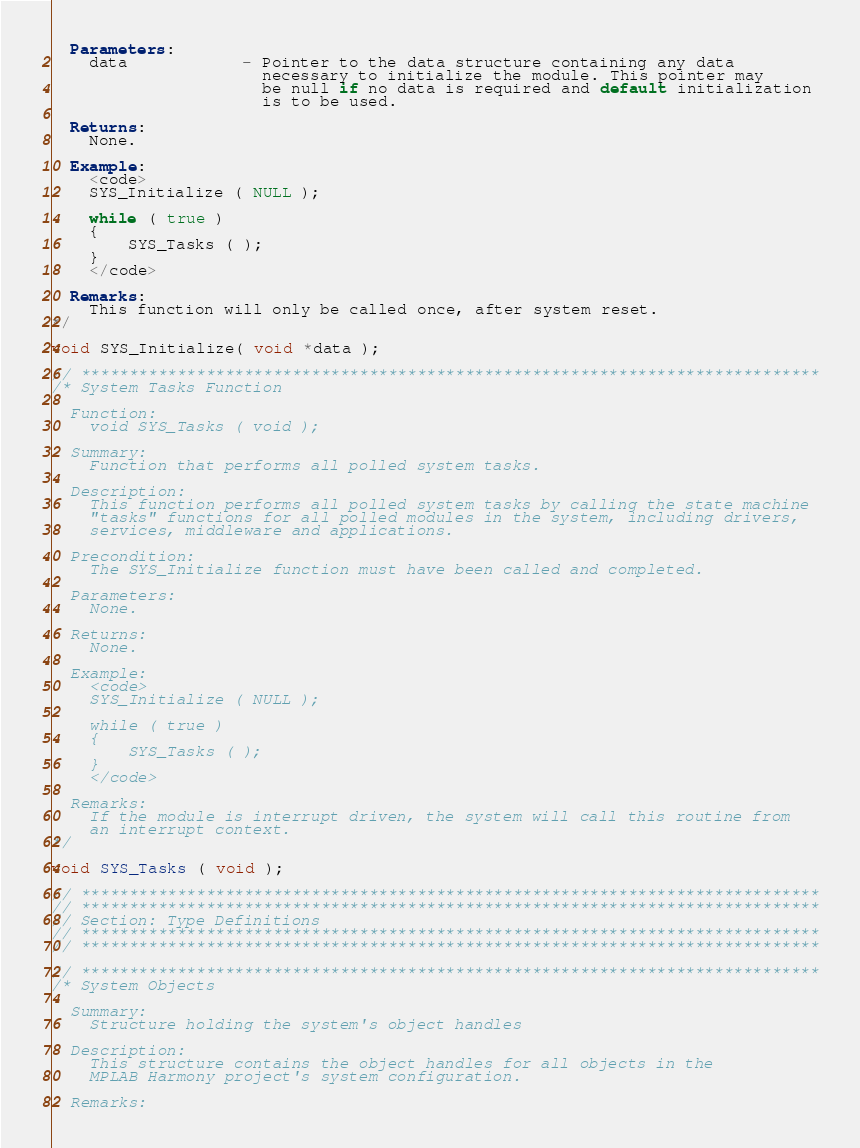<code> <loc_0><loc_0><loc_500><loc_500><_C_>  Parameters:
    data            - Pointer to the data structure containing any data
                      necessary to initialize the module. This pointer may
                      be null if no data is required and default initialization
                      is to be used.

  Returns:
    None.

  Example:
    <code>
    SYS_Initialize ( NULL );

    while ( true )
    {
        SYS_Tasks ( );
    }
    </code>

  Remarks:
    This function will only be called once, after system reset.
*/

void SYS_Initialize( void *data );

// *****************************************************************************
/* System Tasks Function

  Function:
    void SYS_Tasks ( void );

  Summary:
    Function that performs all polled system tasks.

  Description:
    This function performs all polled system tasks by calling the state machine
    "tasks" functions for all polled modules in the system, including drivers,
    services, middleware and applications.

  Precondition:
    The SYS_Initialize function must have been called and completed.

  Parameters:
    None.

  Returns:
    None.

  Example:
    <code>
    SYS_Initialize ( NULL );

    while ( true )
    {
        SYS_Tasks ( );
    }
    </code>

  Remarks:
    If the module is interrupt driven, the system will call this routine from
    an interrupt context.
*/

void SYS_Tasks ( void );

// *****************************************************************************
// *****************************************************************************
// Section: Type Definitions
// *****************************************************************************
// *****************************************************************************

// *****************************************************************************
/* System Objects

  Summary:
    Structure holding the system's object handles

  Description:
    This structure contains the object handles for all objects in the
    MPLAB Harmony project's system configuration.

  Remarks:</code> 